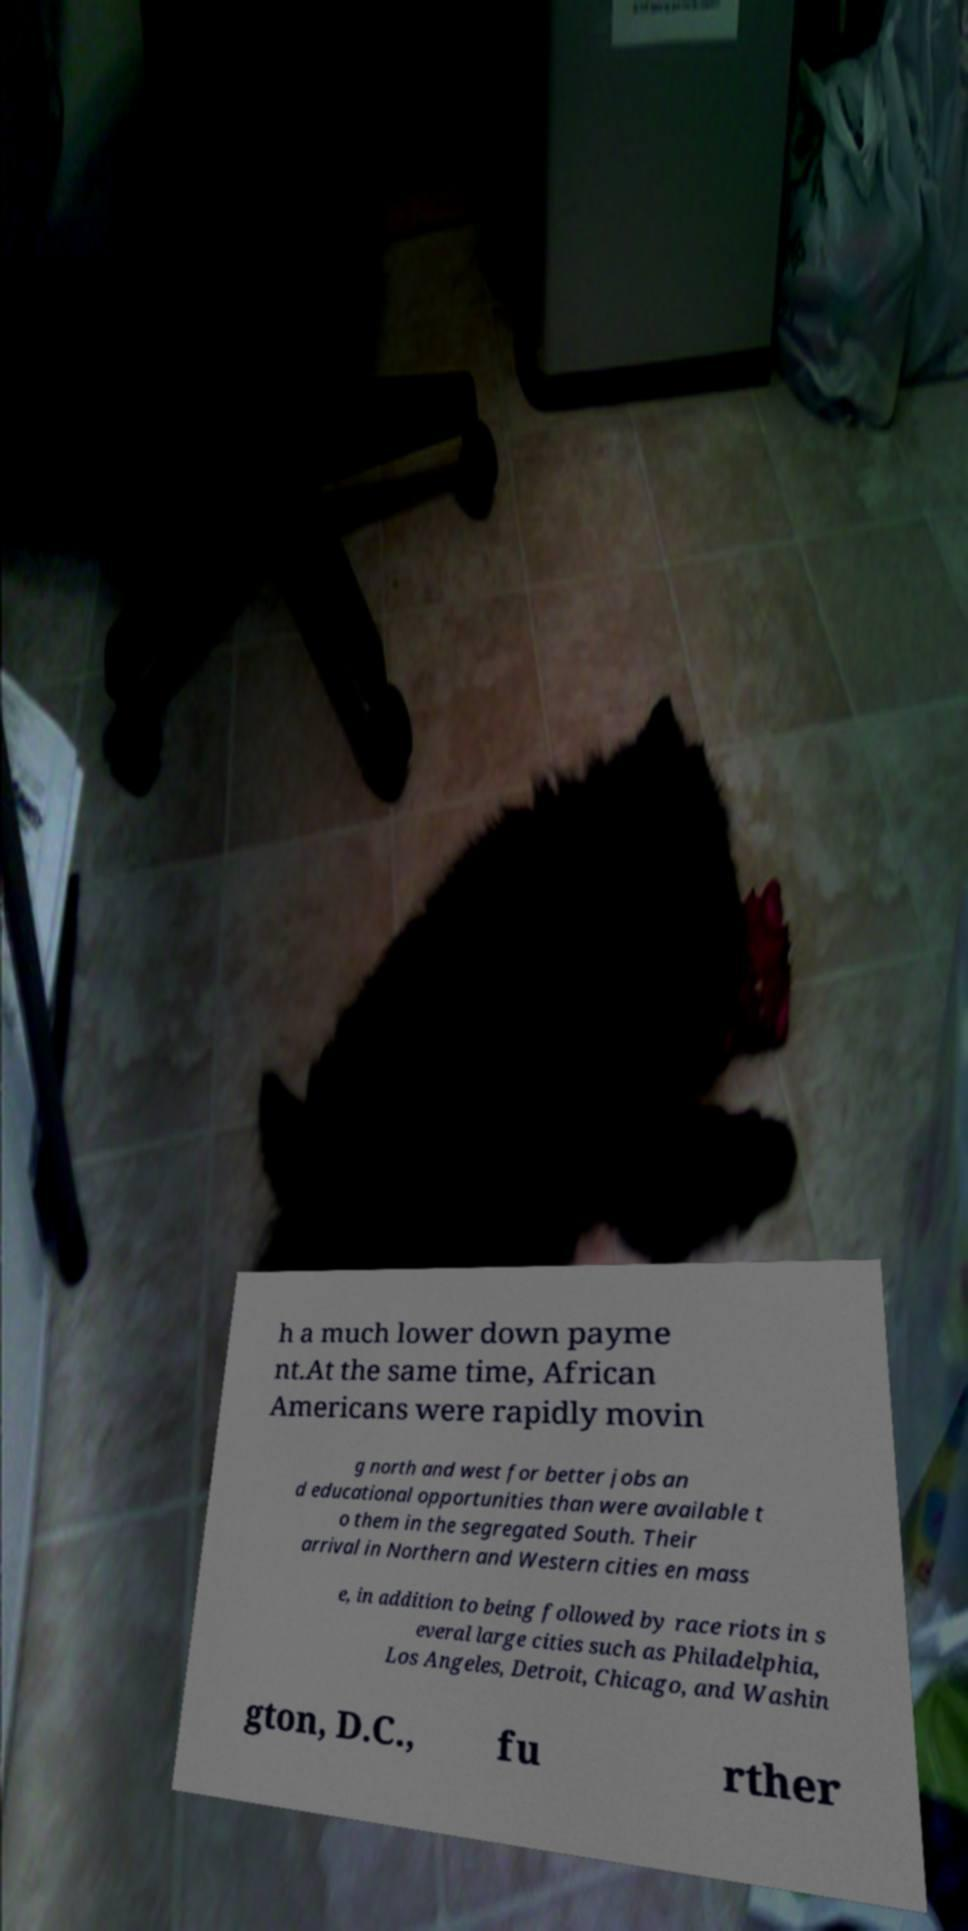I need the written content from this picture converted into text. Can you do that? h a much lower down payme nt.At the same time, African Americans were rapidly movin g north and west for better jobs an d educational opportunities than were available t o them in the segregated South. Their arrival in Northern and Western cities en mass e, in addition to being followed by race riots in s everal large cities such as Philadelphia, Los Angeles, Detroit, Chicago, and Washin gton, D.C., fu rther 